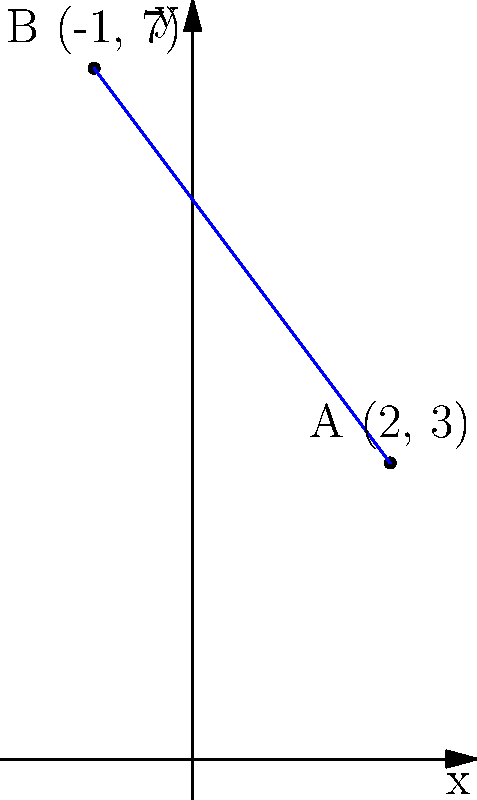As an aspiring actuary, you're working on a project that requires calculating distances between different insurance claim locations. Given two points on a coordinate plane, A(2, 3) and B(-1, 7), find the distance between them using the distance formula. To find the distance between two points, we use the distance formula:

$$ d = \sqrt{(x_2 - x_1)^2 + (y_2 - y_1)^2} $$

Where $(x_1, y_1)$ are the coordinates of the first point and $(x_2, y_2)$ are the coordinates of the second point.

Step 1: Identify the coordinates
Point A: $(x_1, y_1) = (2, 3)$
Point B: $(x_2, y_2) = (-1, 7)$

Step 2: Plug the coordinates into the formula
$$ d = \sqrt{(-1 - 2)^2 + (7 - 3)^2} $$

Step 3: Simplify the expressions inside the parentheses
$$ d = \sqrt{(-3)^2 + (4)^2} $$

Step 4: Calculate the squares
$$ d = \sqrt{9 + 16} $$

Step 5: Add the numbers under the square root
$$ d = \sqrt{25} $$

Step 6: Simplify the square root
$$ d = 5 $$

Therefore, the distance between points A and B is 5 units.
Answer: 5 units 